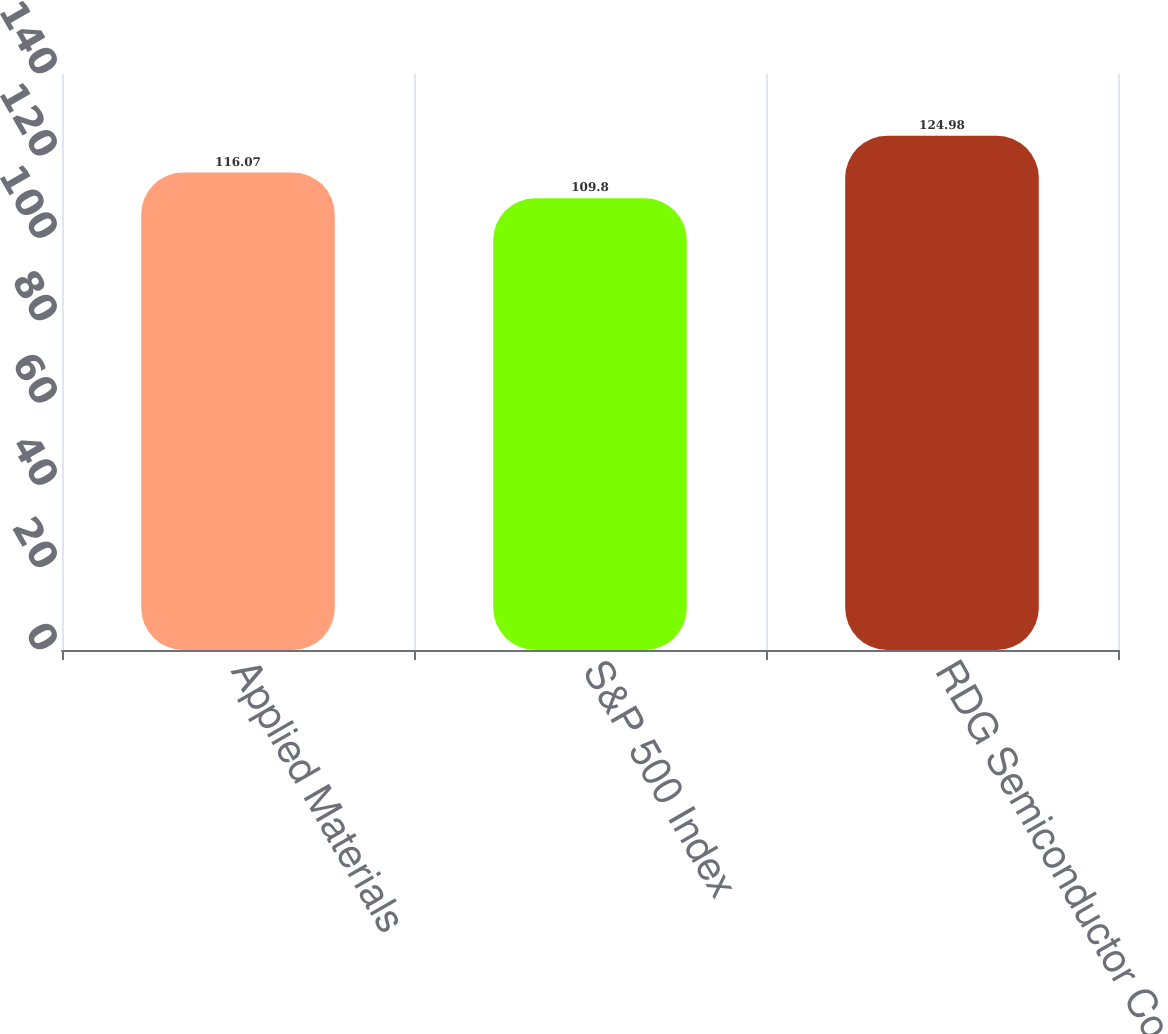Convert chart to OTSL. <chart><loc_0><loc_0><loc_500><loc_500><bar_chart><fcel>Applied Materials<fcel>S&P 500 Index<fcel>RDG Semiconductor Composite<nl><fcel>116.07<fcel>109.8<fcel>124.98<nl></chart> 